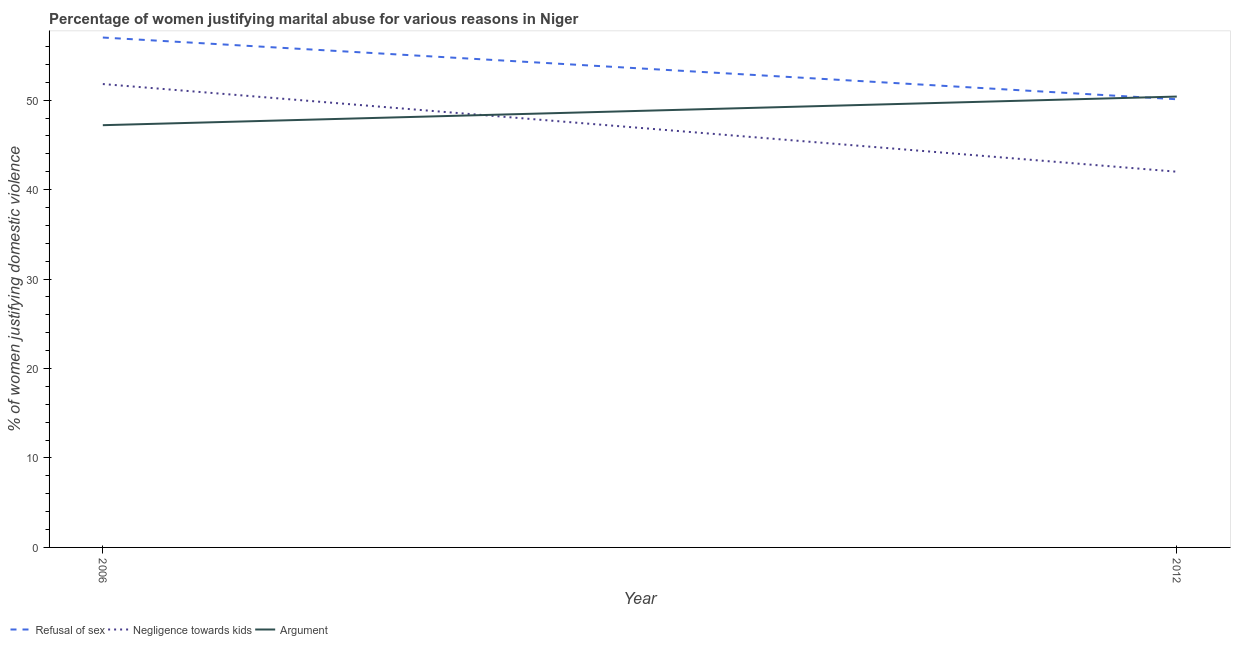How many different coloured lines are there?
Your response must be concise. 3. What is the percentage of women justifying domestic violence due to negligence towards kids in 2006?
Make the answer very short. 51.8. Across all years, what is the maximum percentage of women justifying domestic violence due to negligence towards kids?
Provide a short and direct response. 51.8. Across all years, what is the minimum percentage of women justifying domestic violence due to arguments?
Keep it short and to the point. 47.2. In which year was the percentage of women justifying domestic violence due to arguments minimum?
Ensure brevity in your answer.  2006. What is the total percentage of women justifying domestic violence due to arguments in the graph?
Give a very brief answer. 97.6. What is the difference between the percentage of women justifying domestic violence due to negligence towards kids in 2006 and that in 2012?
Make the answer very short. 9.8. What is the difference between the percentage of women justifying domestic violence due to arguments in 2012 and the percentage of women justifying domestic violence due to negligence towards kids in 2006?
Offer a terse response. -1.4. What is the average percentage of women justifying domestic violence due to refusal of sex per year?
Your answer should be very brief. 53.55. In the year 2012, what is the difference between the percentage of women justifying domestic violence due to negligence towards kids and percentage of women justifying domestic violence due to refusal of sex?
Offer a terse response. -8.1. In how many years, is the percentage of women justifying domestic violence due to negligence towards kids greater than 22 %?
Give a very brief answer. 2. What is the ratio of the percentage of women justifying domestic violence due to arguments in 2006 to that in 2012?
Offer a terse response. 0.94. In how many years, is the percentage of women justifying domestic violence due to negligence towards kids greater than the average percentage of women justifying domestic violence due to negligence towards kids taken over all years?
Your answer should be compact. 1. Is it the case that in every year, the sum of the percentage of women justifying domestic violence due to refusal of sex and percentage of women justifying domestic violence due to negligence towards kids is greater than the percentage of women justifying domestic violence due to arguments?
Your answer should be very brief. Yes. Is the percentage of women justifying domestic violence due to negligence towards kids strictly greater than the percentage of women justifying domestic violence due to refusal of sex over the years?
Keep it short and to the point. No. How many lines are there?
Your answer should be very brief. 3. How many years are there in the graph?
Ensure brevity in your answer.  2. What is the difference between two consecutive major ticks on the Y-axis?
Offer a very short reply. 10. What is the title of the graph?
Ensure brevity in your answer.  Percentage of women justifying marital abuse for various reasons in Niger. Does "Ages 15-20" appear as one of the legend labels in the graph?
Your answer should be compact. No. What is the label or title of the X-axis?
Make the answer very short. Year. What is the label or title of the Y-axis?
Ensure brevity in your answer.  % of women justifying domestic violence. What is the % of women justifying domestic violence of Negligence towards kids in 2006?
Your answer should be very brief. 51.8. What is the % of women justifying domestic violence of Argument in 2006?
Your answer should be very brief. 47.2. What is the % of women justifying domestic violence in Refusal of sex in 2012?
Your response must be concise. 50.1. What is the % of women justifying domestic violence in Argument in 2012?
Give a very brief answer. 50.4. Across all years, what is the maximum % of women justifying domestic violence of Refusal of sex?
Give a very brief answer. 57. Across all years, what is the maximum % of women justifying domestic violence in Negligence towards kids?
Your answer should be compact. 51.8. Across all years, what is the maximum % of women justifying domestic violence of Argument?
Give a very brief answer. 50.4. Across all years, what is the minimum % of women justifying domestic violence of Refusal of sex?
Provide a short and direct response. 50.1. Across all years, what is the minimum % of women justifying domestic violence in Negligence towards kids?
Provide a succinct answer. 42. Across all years, what is the minimum % of women justifying domestic violence of Argument?
Your answer should be compact. 47.2. What is the total % of women justifying domestic violence of Refusal of sex in the graph?
Your response must be concise. 107.1. What is the total % of women justifying domestic violence in Negligence towards kids in the graph?
Provide a short and direct response. 93.8. What is the total % of women justifying domestic violence in Argument in the graph?
Make the answer very short. 97.6. What is the difference between the % of women justifying domestic violence in Refusal of sex in 2006 and that in 2012?
Give a very brief answer. 6.9. What is the difference between the % of women justifying domestic violence of Refusal of sex in 2006 and the % of women justifying domestic violence of Negligence towards kids in 2012?
Your answer should be very brief. 15. What is the difference between the % of women justifying domestic violence in Negligence towards kids in 2006 and the % of women justifying domestic violence in Argument in 2012?
Your answer should be very brief. 1.4. What is the average % of women justifying domestic violence in Refusal of sex per year?
Give a very brief answer. 53.55. What is the average % of women justifying domestic violence in Negligence towards kids per year?
Offer a very short reply. 46.9. What is the average % of women justifying domestic violence of Argument per year?
Your response must be concise. 48.8. In the year 2006, what is the difference between the % of women justifying domestic violence of Refusal of sex and % of women justifying domestic violence of Argument?
Your answer should be compact. 9.8. In the year 2012, what is the difference between the % of women justifying domestic violence in Refusal of sex and % of women justifying domestic violence in Negligence towards kids?
Offer a very short reply. 8.1. In the year 2012, what is the difference between the % of women justifying domestic violence in Refusal of sex and % of women justifying domestic violence in Argument?
Offer a terse response. -0.3. In the year 2012, what is the difference between the % of women justifying domestic violence of Negligence towards kids and % of women justifying domestic violence of Argument?
Your answer should be compact. -8.4. What is the ratio of the % of women justifying domestic violence in Refusal of sex in 2006 to that in 2012?
Your answer should be very brief. 1.14. What is the ratio of the % of women justifying domestic violence of Negligence towards kids in 2006 to that in 2012?
Your answer should be very brief. 1.23. What is the ratio of the % of women justifying domestic violence in Argument in 2006 to that in 2012?
Provide a short and direct response. 0.94. What is the difference between the highest and the second highest % of women justifying domestic violence of Refusal of sex?
Offer a very short reply. 6.9. What is the difference between the highest and the second highest % of women justifying domestic violence of Argument?
Keep it short and to the point. 3.2. What is the difference between the highest and the lowest % of women justifying domestic violence of Negligence towards kids?
Your answer should be very brief. 9.8. 